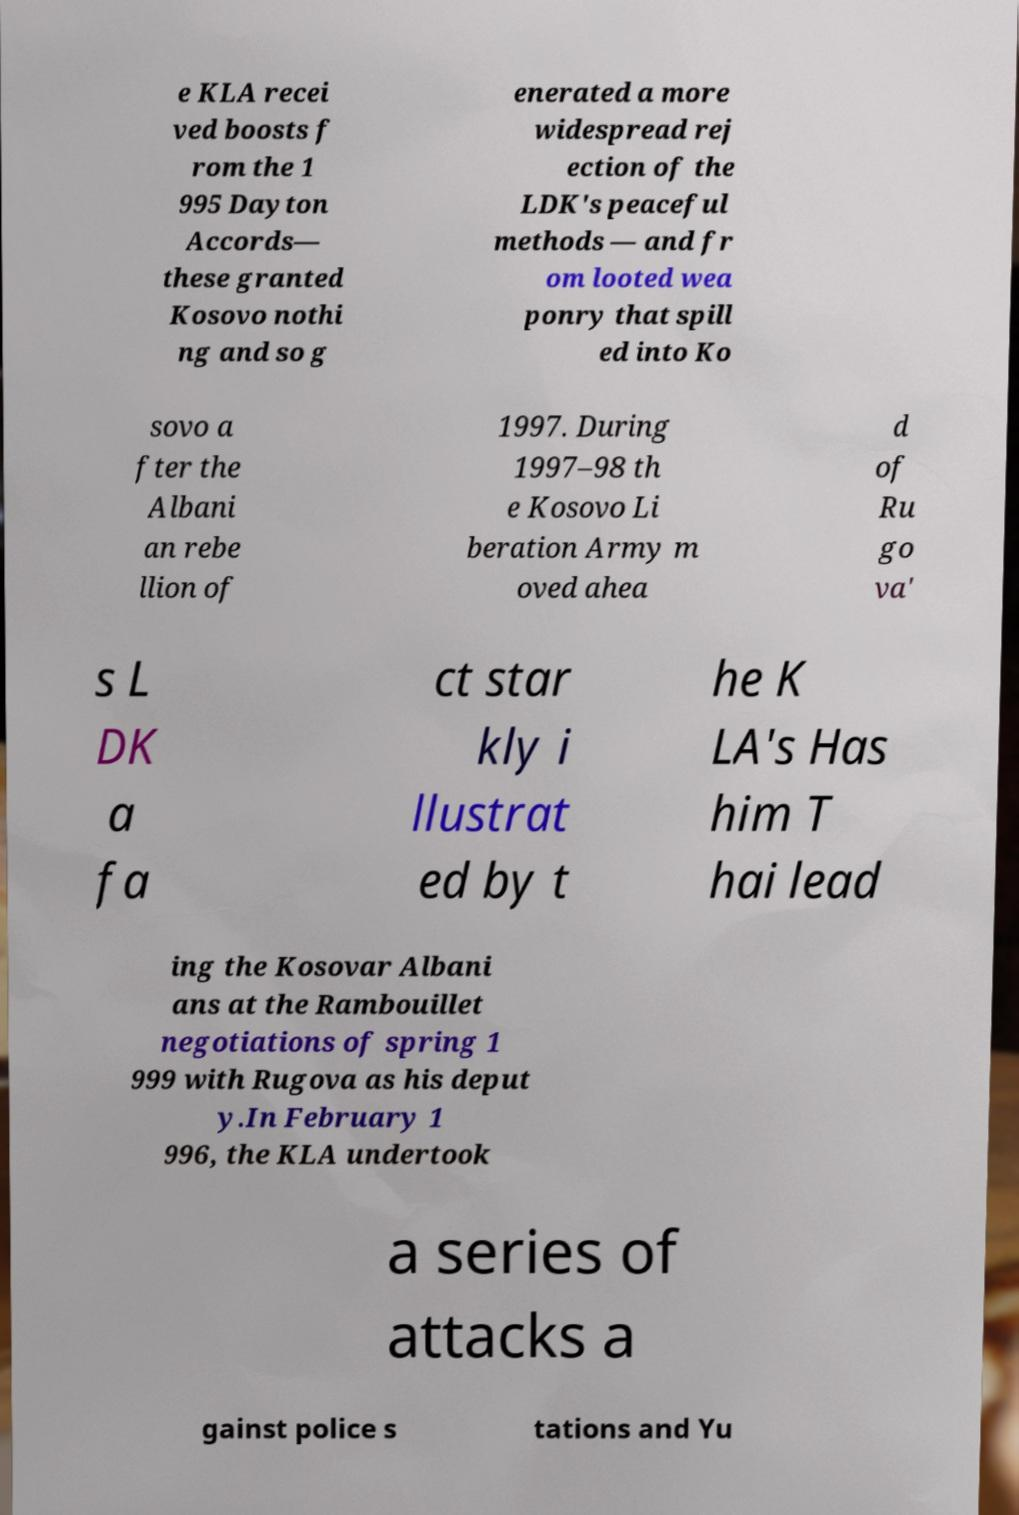Can you accurately transcribe the text from the provided image for me? e KLA recei ved boosts f rom the 1 995 Dayton Accords— these granted Kosovo nothi ng and so g enerated a more widespread rej ection of the LDK's peaceful methods — and fr om looted wea ponry that spill ed into Ko sovo a fter the Albani an rebe llion of 1997. During 1997–98 th e Kosovo Li beration Army m oved ahea d of Ru go va' s L DK a fa ct star kly i llustrat ed by t he K LA's Has him T hai lead ing the Kosovar Albani ans at the Rambouillet negotiations of spring 1 999 with Rugova as his deput y.In February 1 996, the KLA undertook a series of attacks a gainst police s tations and Yu 